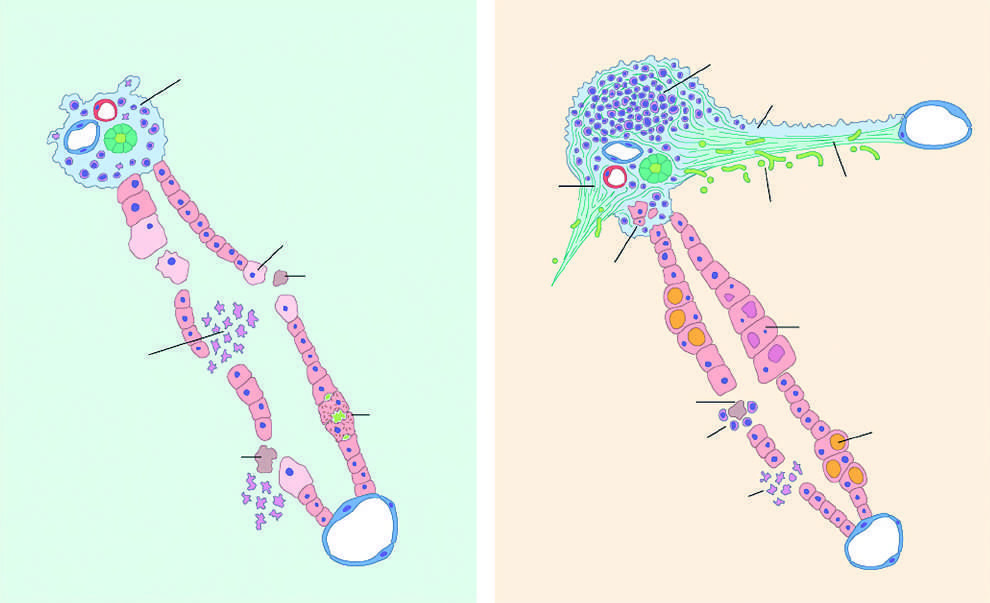s the left atrium very little portal mononuclear infiltration in acute hepatitis or sometimes none at all?
Answer the question using a single word or phrase. No 